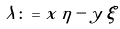<formula> <loc_0><loc_0><loc_500><loc_500>\lambda \colon = x \, \eta - y \, \xi</formula> 